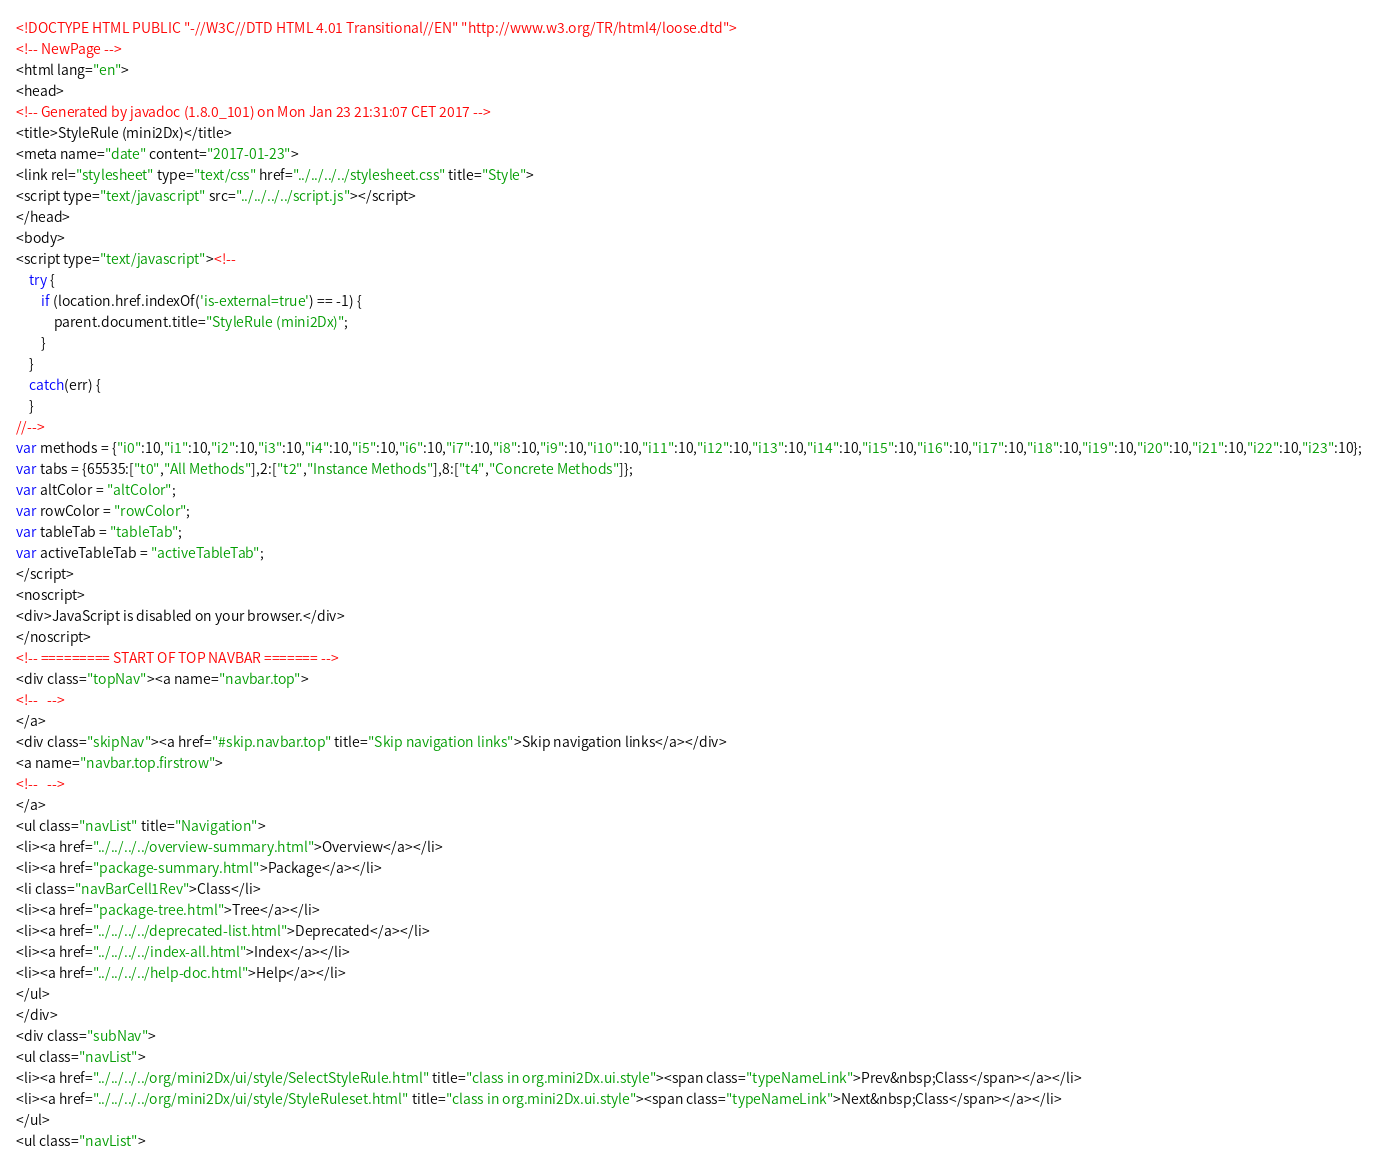<code> <loc_0><loc_0><loc_500><loc_500><_HTML_><!DOCTYPE HTML PUBLIC "-//W3C//DTD HTML 4.01 Transitional//EN" "http://www.w3.org/TR/html4/loose.dtd">
<!-- NewPage -->
<html lang="en">
<head>
<!-- Generated by javadoc (1.8.0_101) on Mon Jan 23 21:31:07 CET 2017 -->
<title>StyleRule (mini2Dx)</title>
<meta name="date" content="2017-01-23">
<link rel="stylesheet" type="text/css" href="../../../../stylesheet.css" title="Style">
<script type="text/javascript" src="../../../../script.js"></script>
</head>
<body>
<script type="text/javascript"><!--
    try {
        if (location.href.indexOf('is-external=true') == -1) {
            parent.document.title="StyleRule (mini2Dx)";
        }
    }
    catch(err) {
    }
//-->
var methods = {"i0":10,"i1":10,"i2":10,"i3":10,"i4":10,"i5":10,"i6":10,"i7":10,"i8":10,"i9":10,"i10":10,"i11":10,"i12":10,"i13":10,"i14":10,"i15":10,"i16":10,"i17":10,"i18":10,"i19":10,"i20":10,"i21":10,"i22":10,"i23":10};
var tabs = {65535:["t0","All Methods"],2:["t2","Instance Methods"],8:["t4","Concrete Methods"]};
var altColor = "altColor";
var rowColor = "rowColor";
var tableTab = "tableTab";
var activeTableTab = "activeTableTab";
</script>
<noscript>
<div>JavaScript is disabled on your browser.</div>
</noscript>
<!-- ========= START OF TOP NAVBAR ======= -->
<div class="topNav"><a name="navbar.top">
<!--   -->
</a>
<div class="skipNav"><a href="#skip.navbar.top" title="Skip navigation links">Skip navigation links</a></div>
<a name="navbar.top.firstrow">
<!--   -->
</a>
<ul class="navList" title="Navigation">
<li><a href="../../../../overview-summary.html">Overview</a></li>
<li><a href="package-summary.html">Package</a></li>
<li class="navBarCell1Rev">Class</li>
<li><a href="package-tree.html">Tree</a></li>
<li><a href="../../../../deprecated-list.html">Deprecated</a></li>
<li><a href="../../../../index-all.html">Index</a></li>
<li><a href="../../../../help-doc.html">Help</a></li>
</ul>
</div>
<div class="subNav">
<ul class="navList">
<li><a href="../../../../org/mini2Dx/ui/style/SelectStyleRule.html" title="class in org.mini2Dx.ui.style"><span class="typeNameLink">Prev&nbsp;Class</span></a></li>
<li><a href="../../../../org/mini2Dx/ui/style/StyleRuleset.html" title="class in org.mini2Dx.ui.style"><span class="typeNameLink">Next&nbsp;Class</span></a></li>
</ul>
<ul class="navList"></code> 